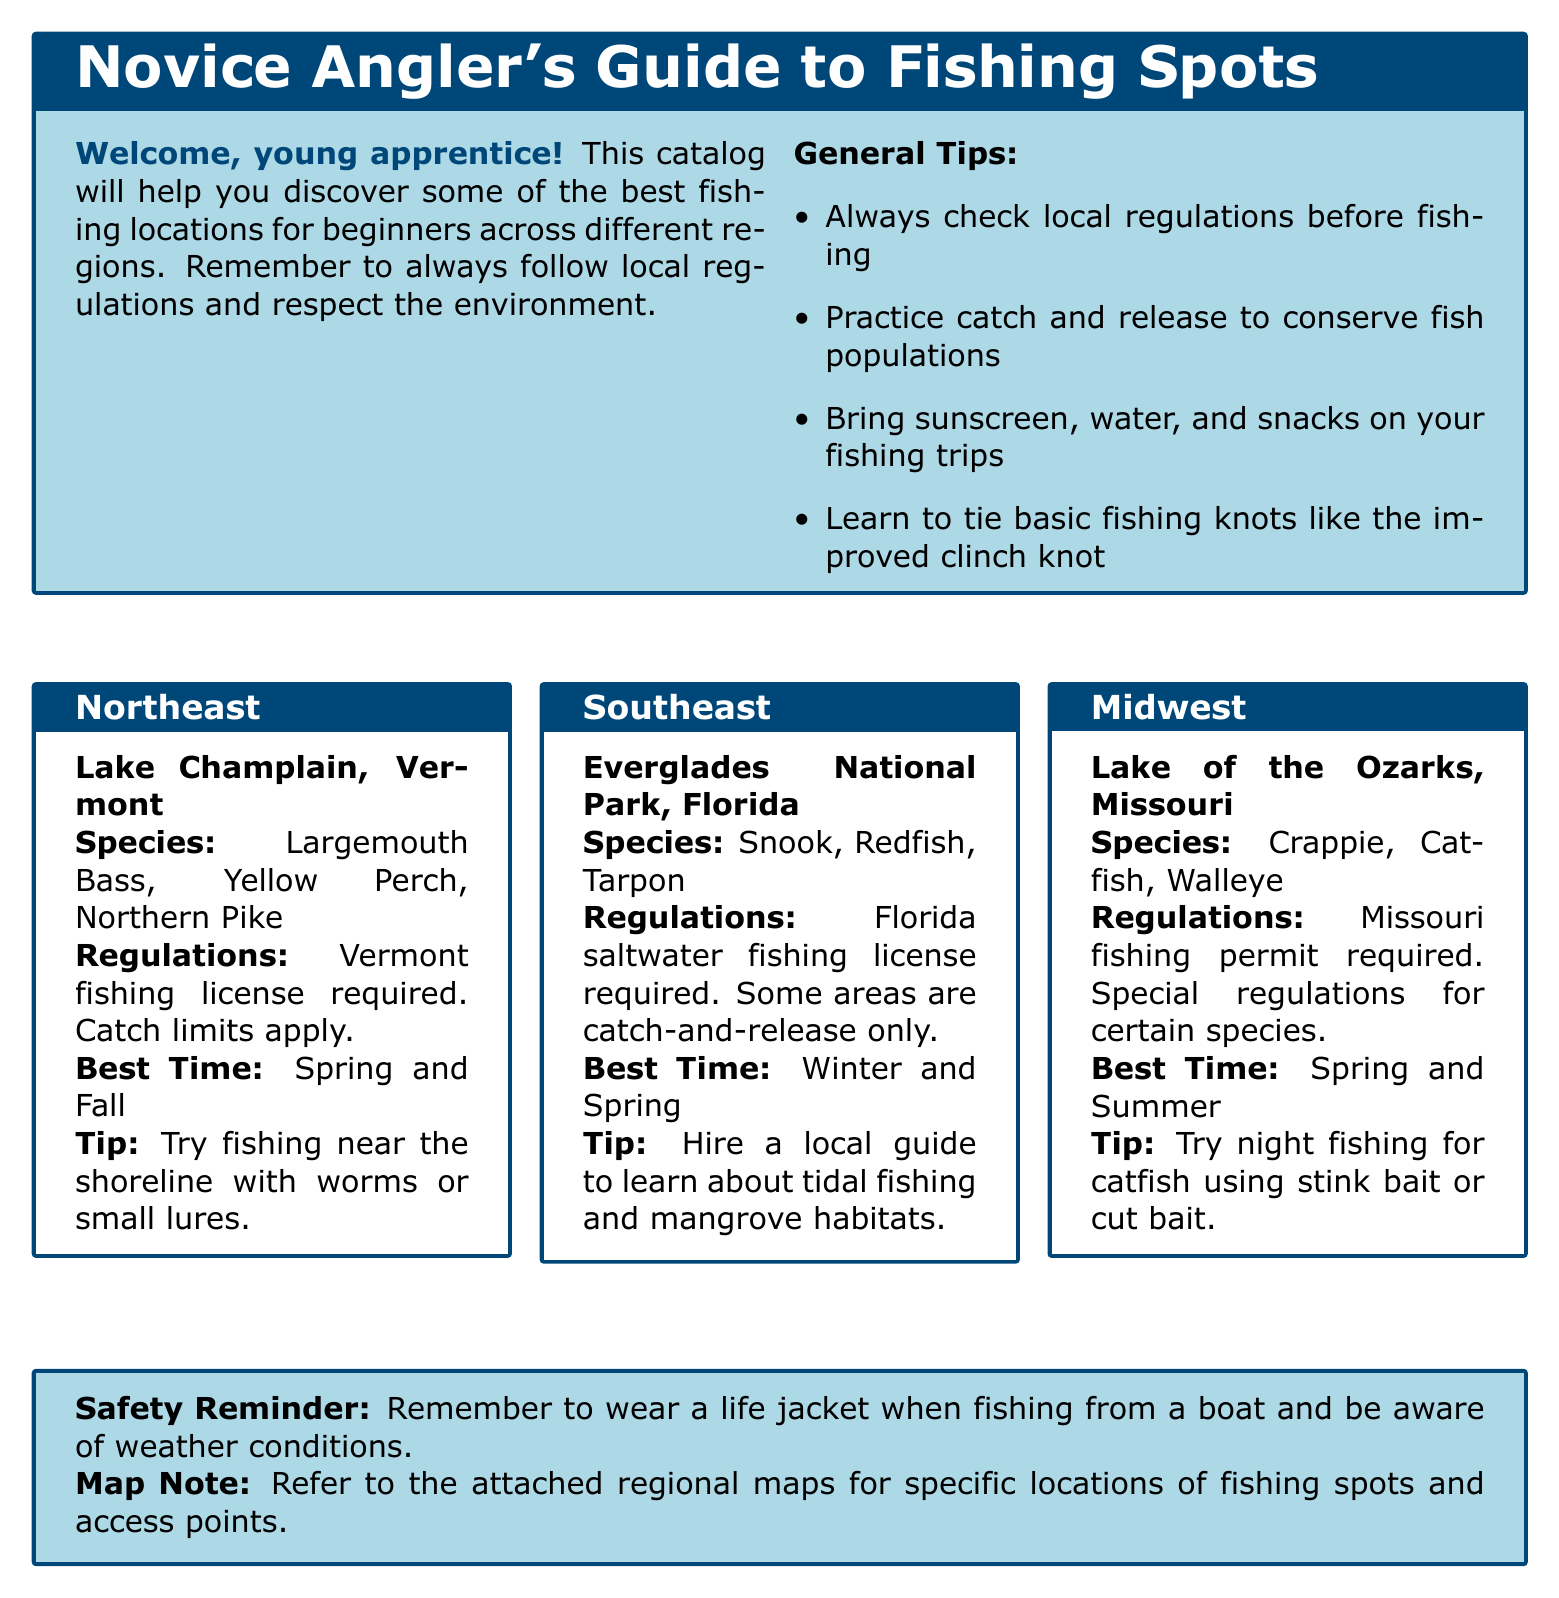What species can be found in Lake Champlain? The document lists the species available in Lake Champlain, which include Largemouth Bass, Yellow Perch, and Northern Pike.
Answer: Largemouth Bass, Yellow Perch, Northern Pike What is required to fish in Everglades National Park? The regulations for fishing in Everglades National Park state that a Florida saltwater fishing license is required.
Answer: Florida saltwater fishing license When is the best time to fish in Lake of the Ozarks? The document specifies that the best time for fishing in Lake of the Ozarks is Spring and Summer.
Answer: Spring and Summer What fishing technique is recommended for catfish in Lake of the Ozarks? The tip provided for catfishing in Lake of the Ozarks suggests trying night fishing using stink bait or cut bait.
Answer: Night fishing with stink bait or cut bait What safety equipment is advised when fishing from a boat? The document includes a safety reminder that mentions wearing a life jacket when fishing from a boat.
Answer: Life jacket Which region is associated with Snook and Redfish? The information indicates that Snook and Redfish are species found in Everglades National Park, which is in the Southeast region.
Answer: Southeast What does the document suggest for respecting fish populations? The general tips section advises practicing catch and release to help conserve fish populations.
Answer: Catch and release What type of fishing license is required in Vermont? The regulations for fishing in Vermont state that a Vermont fishing license is required.
Answer: Vermont fishing license 